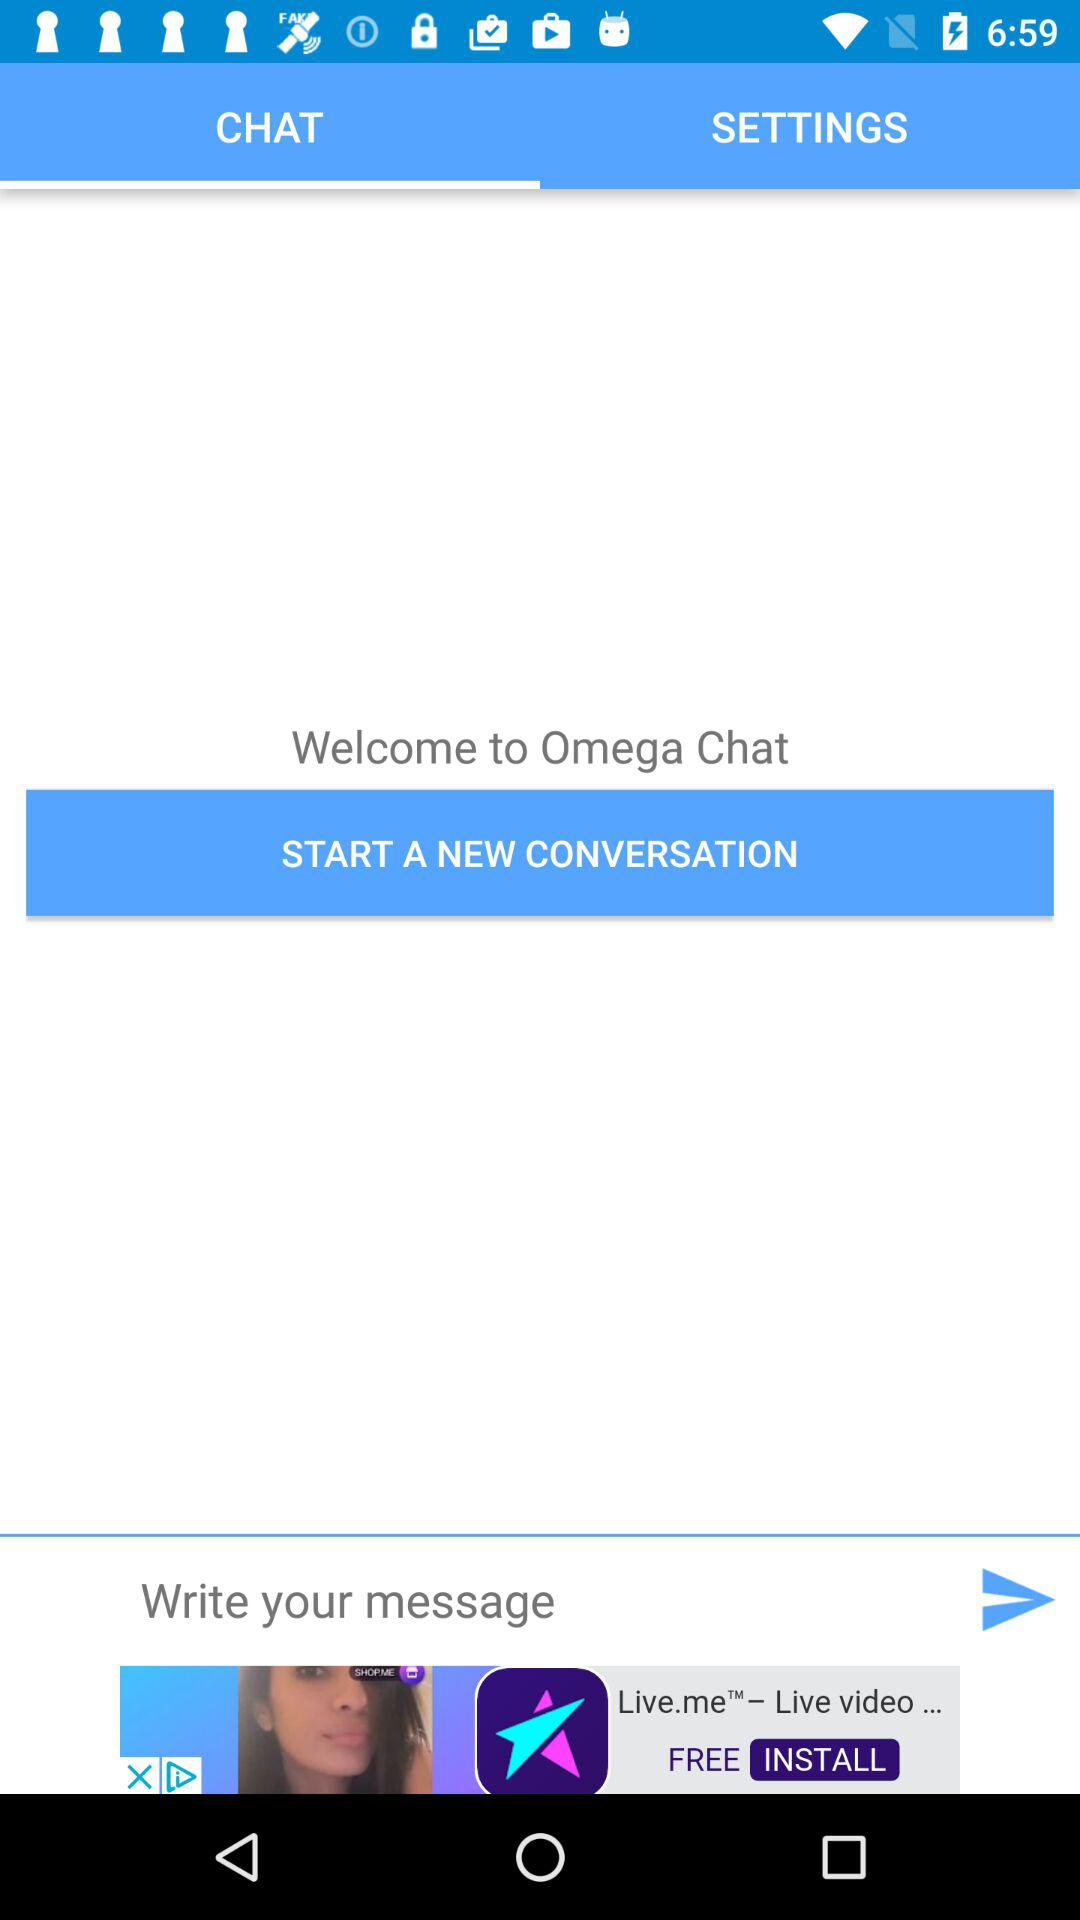Which tab is selected? The selected tab is "CHAT". 